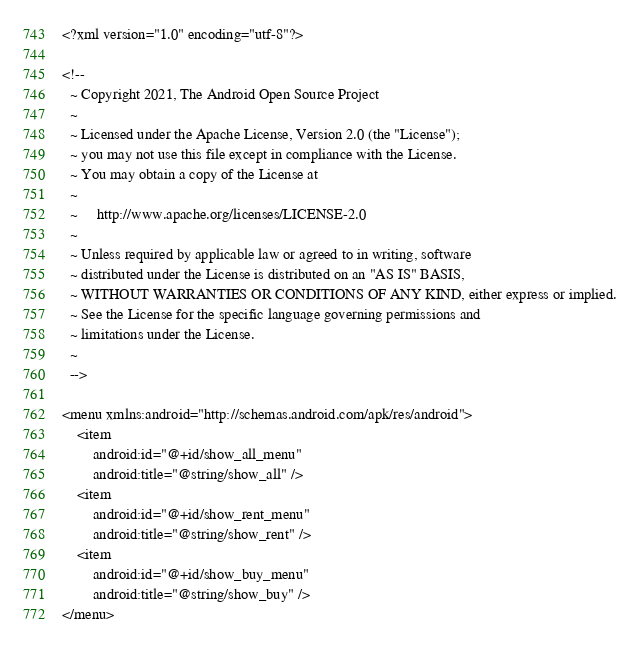<code> <loc_0><loc_0><loc_500><loc_500><_XML_><?xml version="1.0" encoding="utf-8"?>

<!--
  ~ Copyright 2021, The Android Open Source Project
  ~
  ~ Licensed under the Apache License, Version 2.0 (the "License");
  ~ you may not use this file except in compliance with the License.
  ~ You may obtain a copy of the License at
  ~
  ~     http://www.apache.org/licenses/LICENSE-2.0
  ~
  ~ Unless required by applicable law or agreed to in writing, software
  ~ distributed under the License is distributed on an "AS IS" BASIS,
  ~ WITHOUT WARRANTIES OR CONDITIONS OF ANY KIND, either express or implied.
  ~ See the License for the specific language governing permissions and
  ~ limitations under the License.
  ~
  -->

<menu xmlns:android="http://schemas.android.com/apk/res/android">
    <item
        android:id="@+id/show_all_menu"
        android:title="@string/show_all" />
    <item
        android:id="@+id/show_rent_menu"
        android:title="@string/show_rent" />
    <item
        android:id="@+id/show_buy_menu"
        android:title="@string/show_buy" />
</menu>
</code> 